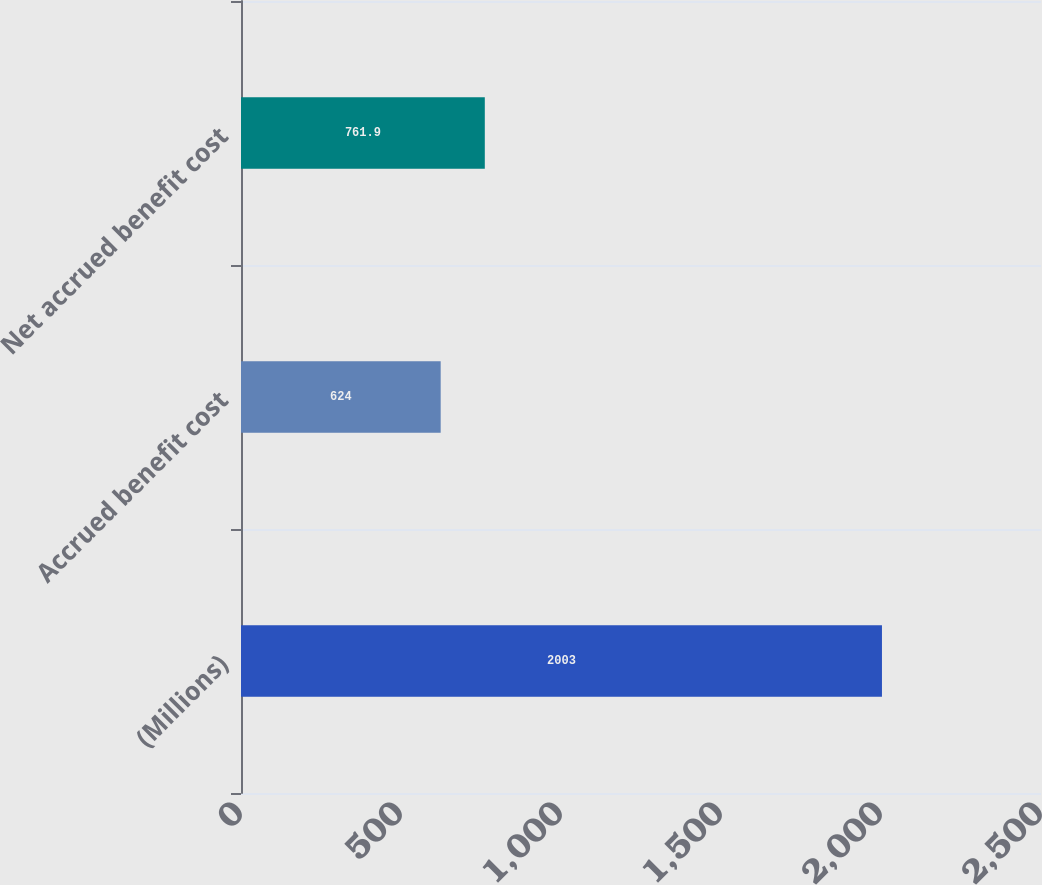<chart> <loc_0><loc_0><loc_500><loc_500><bar_chart><fcel>(Millions)<fcel>Accrued benefit cost<fcel>Net accrued benefit cost<nl><fcel>2003<fcel>624<fcel>761.9<nl></chart> 